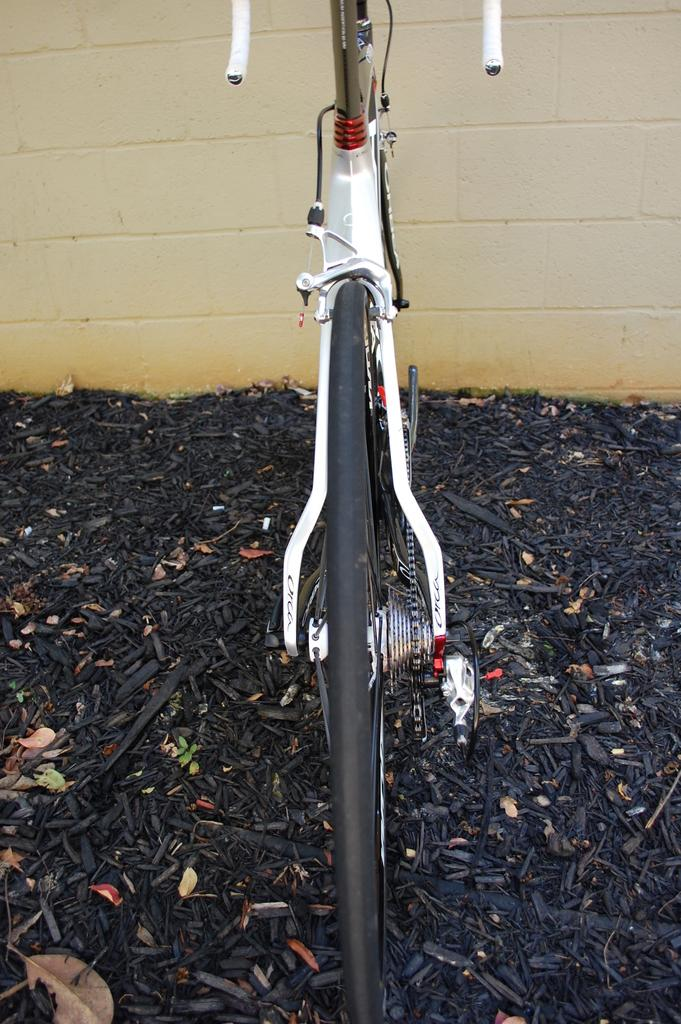What is the main subject of the picture? The main subject of the picture is a bicycle. Where is the bicycle located in the image? The bicycle is parked on a dried twigs surface. What is the color of the dried twigs surface? The dried twigs surface is black in color. What can be seen in the background of the picture? There is a wall in the background of the picture. What is the color of the wall? The wall is cream in color. What is the price of the bicycle in the image? The price of the bicycle is not mentioned in the image, so it cannot be determined. Is there an agreement between the bicycle and the wall in the image? There is no indication of an agreement between the bicycle and the wall in the image. 